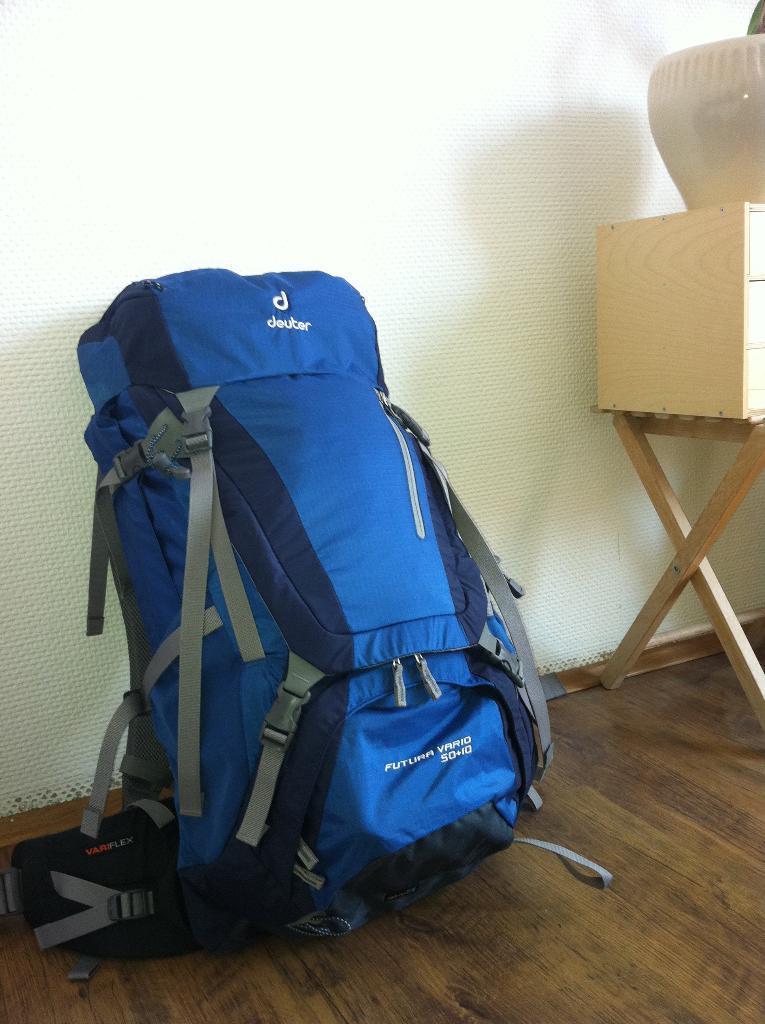Describe this image in one or two sentences. In this image I see a blue colored bag which is on the floor and there is a table over here and there is a thing on it. In the background I see the wall. 